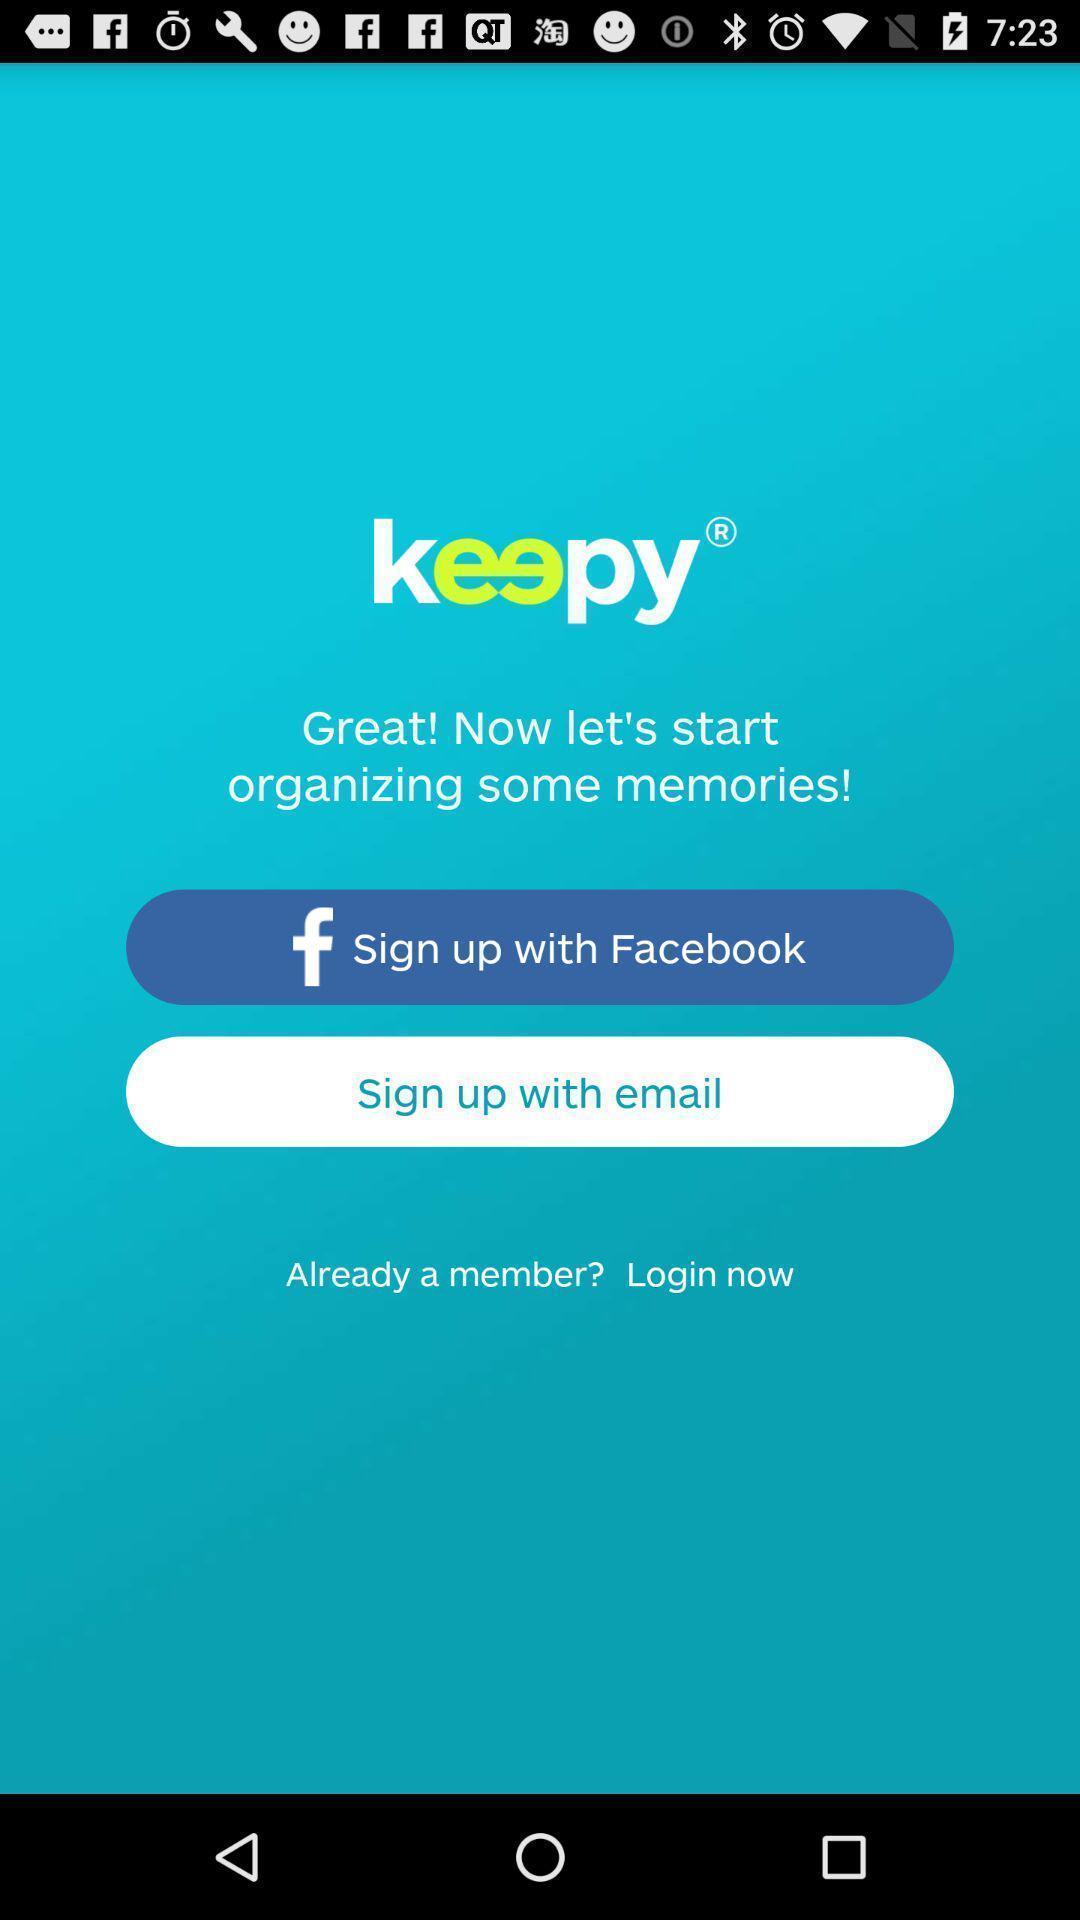Tell me about the visual elements in this screen capture. Sign up page. 